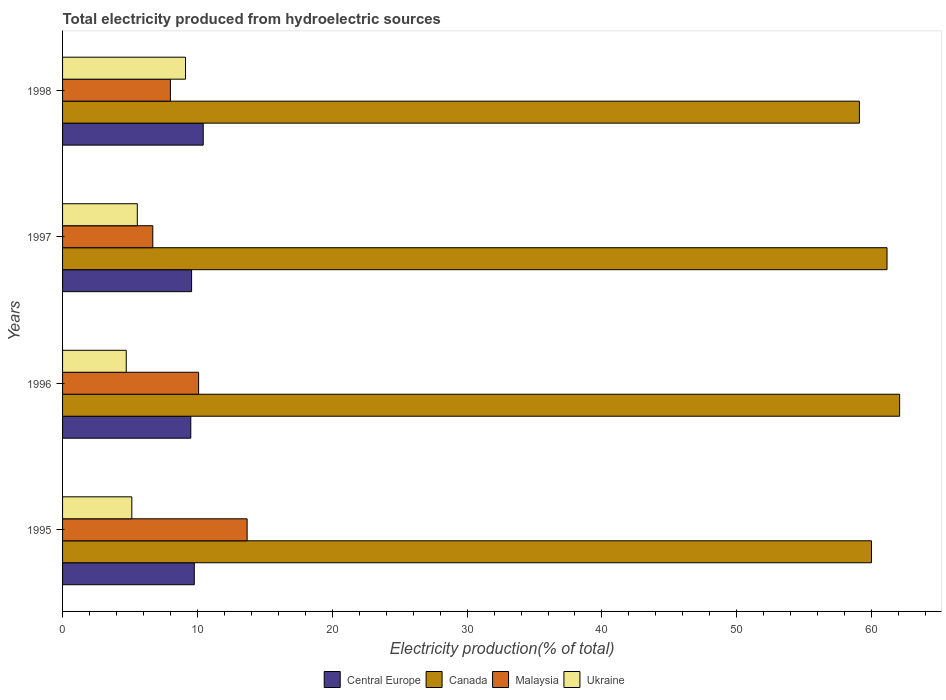How many different coloured bars are there?
Your response must be concise. 4. How many groups of bars are there?
Give a very brief answer. 4. Are the number of bars per tick equal to the number of legend labels?
Your answer should be very brief. Yes. How many bars are there on the 4th tick from the top?
Keep it short and to the point. 4. What is the total electricity produced in Ukraine in 1997?
Your answer should be very brief. 5.54. Across all years, what is the maximum total electricity produced in Ukraine?
Provide a short and direct response. 9.12. Across all years, what is the minimum total electricity produced in Malaysia?
Offer a terse response. 6.69. In which year was the total electricity produced in Central Europe minimum?
Ensure brevity in your answer.  1996. What is the total total electricity produced in Malaysia in the graph?
Your answer should be very brief. 38.46. What is the difference between the total electricity produced in Ukraine in 1995 and that in 1996?
Offer a terse response. 0.41. What is the difference between the total electricity produced in Ukraine in 1997 and the total electricity produced in Malaysia in 1995?
Offer a terse response. -8.14. What is the average total electricity produced in Central Europe per year?
Provide a succinct answer. 9.82. In the year 1996, what is the difference between the total electricity produced in Ukraine and total electricity produced in Malaysia?
Ensure brevity in your answer.  -5.37. What is the ratio of the total electricity produced in Central Europe in 1997 to that in 1998?
Offer a very short reply. 0.92. What is the difference between the highest and the second highest total electricity produced in Ukraine?
Provide a short and direct response. 3.57. What is the difference between the highest and the lowest total electricity produced in Canada?
Keep it short and to the point. 2.98. Is the sum of the total electricity produced in Canada in 1995 and 1997 greater than the maximum total electricity produced in Central Europe across all years?
Give a very brief answer. Yes. What does the 4th bar from the top in 1995 represents?
Make the answer very short. Central Europe. What does the 1st bar from the bottom in 1996 represents?
Provide a succinct answer. Central Europe. Is it the case that in every year, the sum of the total electricity produced in Central Europe and total electricity produced in Malaysia is greater than the total electricity produced in Canada?
Offer a terse response. No. How many bars are there?
Make the answer very short. 16. What is the difference between two consecutive major ticks on the X-axis?
Provide a short and direct response. 10. Does the graph contain any zero values?
Offer a very short reply. No. Does the graph contain grids?
Provide a short and direct response. No. How many legend labels are there?
Ensure brevity in your answer.  4. What is the title of the graph?
Offer a very short reply. Total electricity produced from hydroelectric sources. What is the Electricity production(% of total) in Central Europe in 1995?
Keep it short and to the point. 9.77. What is the Electricity production(% of total) of Canada in 1995?
Make the answer very short. 59.99. What is the Electricity production(% of total) of Malaysia in 1995?
Provide a succinct answer. 13.69. What is the Electricity production(% of total) in Ukraine in 1995?
Offer a terse response. 5.14. What is the Electricity production(% of total) in Central Europe in 1996?
Ensure brevity in your answer.  9.51. What is the Electricity production(% of total) in Canada in 1996?
Provide a short and direct response. 62.08. What is the Electricity production(% of total) in Malaysia in 1996?
Keep it short and to the point. 10.09. What is the Electricity production(% of total) of Ukraine in 1996?
Provide a succinct answer. 4.72. What is the Electricity production(% of total) in Central Europe in 1997?
Give a very brief answer. 9.57. What is the Electricity production(% of total) of Canada in 1997?
Your response must be concise. 61.14. What is the Electricity production(% of total) in Malaysia in 1997?
Provide a short and direct response. 6.69. What is the Electricity production(% of total) in Ukraine in 1997?
Offer a very short reply. 5.54. What is the Electricity production(% of total) of Central Europe in 1998?
Give a very brief answer. 10.43. What is the Electricity production(% of total) in Canada in 1998?
Ensure brevity in your answer.  59.09. What is the Electricity production(% of total) of Malaysia in 1998?
Give a very brief answer. 8. What is the Electricity production(% of total) in Ukraine in 1998?
Offer a terse response. 9.12. Across all years, what is the maximum Electricity production(% of total) of Central Europe?
Your response must be concise. 10.43. Across all years, what is the maximum Electricity production(% of total) in Canada?
Keep it short and to the point. 62.08. Across all years, what is the maximum Electricity production(% of total) of Malaysia?
Give a very brief answer. 13.69. Across all years, what is the maximum Electricity production(% of total) in Ukraine?
Your response must be concise. 9.12. Across all years, what is the minimum Electricity production(% of total) of Central Europe?
Your answer should be very brief. 9.51. Across all years, what is the minimum Electricity production(% of total) in Canada?
Your answer should be very brief. 59.09. Across all years, what is the minimum Electricity production(% of total) of Malaysia?
Your answer should be very brief. 6.69. Across all years, what is the minimum Electricity production(% of total) in Ukraine?
Keep it short and to the point. 4.72. What is the total Electricity production(% of total) of Central Europe in the graph?
Provide a short and direct response. 39.28. What is the total Electricity production(% of total) in Canada in the graph?
Your answer should be very brief. 242.29. What is the total Electricity production(% of total) in Malaysia in the graph?
Your answer should be very brief. 38.46. What is the total Electricity production(% of total) of Ukraine in the graph?
Offer a terse response. 24.52. What is the difference between the Electricity production(% of total) of Central Europe in 1995 and that in 1996?
Give a very brief answer. 0.26. What is the difference between the Electricity production(% of total) of Canada in 1995 and that in 1996?
Your response must be concise. -2.09. What is the difference between the Electricity production(% of total) of Malaysia in 1995 and that in 1996?
Your answer should be compact. 3.6. What is the difference between the Electricity production(% of total) in Ukraine in 1995 and that in 1996?
Your response must be concise. 0.41. What is the difference between the Electricity production(% of total) in Central Europe in 1995 and that in 1997?
Provide a succinct answer. 0.2. What is the difference between the Electricity production(% of total) of Canada in 1995 and that in 1997?
Offer a terse response. -1.15. What is the difference between the Electricity production(% of total) in Malaysia in 1995 and that in 1997?
Ensure brevity in your answer.  7. What is the difference between the Electricity production(% of total) of Ukraine in 1995 and that in 1997?
Ensure brevity in your answer.  -0.41. What is the difference between the Electricity production(% of total) in Central Europe in 1995 and that in 1998?
Offer a very short reply. -0.66. What is the difference between the Electricity production(% of total) of Canada in 1995 and that in 1998?
Your answer should be very brief. 0.89. What is the difference between the Electricity production(% of total) of Malaysia in 1995 and that in 1998?
Your answer should be very brief. 5.69. What is the difference between the Electricity production(% of total) in Ukraine in 1995 and that in 1998?
Your answer should be very brief. -3.98. What is the difference between the Electricity production(% of total) in Central Europe in 1996 and that in 1997?
Provide a short and direct response. -0.06. What is the difference between the Electricity production(% of total) in Canada in 1996 and that in 1997?
Your answer should be very brief. 0.94. What is the difference between the Electricity production(% of total) of Malaysia in 1996 and that in 1997?
Offer a terse response. 3.4. What is the difference between the Electricity production(% of total) of Ukraine in 1996 and that in 1997?
Make the answer very short. -0.82. What is the difference between the Electricity production(% of total) in Central Europe in 1996 and that in 1998?
Give a very brief answer. -0.92. What is the difference between the Electricity production(% of total) of Canada in 1996 and that in 1998?
Ensure brevity in your answer.  2.98. What is the difference between the Electricity production(% of total) of Malaysia in 1996 and that in 1998?
Provide a succinct answer. 2.09. What is the difference between the Electricity production(% of total) in Ukraine in 1996 and that in 1998?
Give a very brief answer. -4.39. What is the difference between the Electricity production(% of total) in Central Europe in 1997 and that in 1998?
Keep it short and to the point. -0.86. What is the difference between the Electricity production(% of total) in Canada in 1997 and that in 1998?
Your response must be concise. 2.05. What is the difference between the Electricity production(% of total) in Malaysia in 1997 and that in 1998?
Offer a terse response. -1.31. What is the difference between the Electricity production(% of total) in Ukraine in 1997 and that in 1998?
Ensure brevity in your answer.  -3.57. What is the difference between the Electricity production(% of total) in Central Europe in 1995 and the Electricity production(% of total) in Canada in 1996?
Ensure brevity in your answer.  -52.31. What is the difference between the Electricity production(% of total) in Central Europe in 1995 and the Electricity production(% of total) in Malaysia in 1996?
Give a very brief answer. -0.32. What is the difference between the Electricity production(% of total) in Central Europe in 1995 and the Electricity production(% of total) in Ukraine in 1996?
Provide a succinct answer. 5.05. What is the difference between the Electricity production(% of total) of Canada in 1995 and the Electricity production(% of total) of Malaysia in 1996?
Give a very brief answer. 49.9. What is the difference between the Electricity production(% of total) of Canada in 1995 and the Electricity production(% of total) of Ukraine in 1996?
Provide a short and direct response. 55.26. What is the difference between the Electricity production(% of total) of Malaysia in 1995 and the Electricity production(% of total) of Ukraine in 1996?
Offer a terse response. 8.96. What is the difference between the Electricity production(% of total) in Central Europe in 1995 and the Electricity production(% of total) in Canada in 1997?
Ensure brevity in your answer.  -51.37. What is the difference between the Electricity production(% of total) of Central Europe in 1995 and the Electricity production(% of total) of Malaysia in 1997?
Provide a succinct answer. 3.08. What is the difference between the Electricity production(% of total) in Central Europe in 1995 and the Electricity production(% of total) in Ukraine in 1997?
Your answer should be very brief. 4.23. What is the difference between the Electricity production(% of total) in Canada in 1995 and the Electricity production(% of total) in Malaysia in 1997?
Ensure brevity in your answer.  53.29. What is the difference between the Electricity production(% of total) in Canada in 1995 and the Electricity production(% of total) in Ukraine in 1997?
Provide a short and direct response. 54.44. What is the difference between the Electricity production(% of total) of Malaysia in 1995 and the Electricity production(% of total) of Ukraine in 1997?
Offer a very short reply. 8.14. What is the difference between the Electricity production(% of total) in Central Europe in 1995 and the Electricity production(% of total) in Canada in 1998?
Make the answer very short. -49.32. What is the difference between the Electricity production(% of total) of Central Europe in 1995 and the Electricity production(% of total) of Malaysia in 1998?
Your answer should be compact. 1.77. What is the difference between the Electricity production(% of total) in Central Europe in 1995 and the Electricity production(% of total) in Ukraine in 1998?
Provide a short and direct response. 0.65. What is the difference between the Electricity production(% of total) of Canada in 1995 and the Electricity production(% of total) of Malaysia in 1998?
Ensure brevity in your answer.  51.99. What is the difference between the Electricity production(% of total) of Canada in 1995 and the Electricity production(% of total) of Ukraine in 1998?
Keep it short and to the point. 50.87. What is the difference between the Electricity production(% of total) of Malaysia in 1995 and the Electricity production(% of total) of Ukraine in 1998?
Provide a succinct answer. 4.57. What is the difference between the Electricity production(% of total) in Central Europe in 1996 and the Electricity production(% of total) in Canada in 1997?
Provide a short and direct response. -51.63. What is the difference between the Electricity production(% of total) of Central Europe in 1996 and the Electricity production(% of total) of Malaysia in 1997?
Make the answer very short. 2.82. What is the difference between the Electricity production(% of total) in Central Europe in 1996 and the Electricity production(% of total) in Ukraine in 1997?
Your answer should be compact. 3.97. What is the difference between the Electricity production(% of total) in Canada in 1996 and the Electricity production(% of total) in Malaysia in 1997?
Keep it short and to the point. 55.38. What is the difference between the Electricity production(% of total) in Canada in 1996 and the Electricity production(% of total) in Ukraine in 1997?
Provide a short and direct response. 56.53. What is the difference between the Electricity production(% of total) of Malaysia in 1996 and the Electricity production(% of total) of Ukraine in 1997?
Your response must be concise. 4.55. What is the difference between the Electricity production(% of total) of Central Europe in 1996 and the Electricity production(% of total) of Canada in 1998?
Your answer should be very brief. -49.58. What is the difference between the Electricity production(% of total) of Central Europe in 1996 and the Electricity production(% of total) of Malaysia in 1998?
Your answer should be compact. 1.51. What is the difference between the Electricity production(% of total) of Central Europe in 1996 and the Electricity production(% of total) of Ukraine in 1998?
Provide a succinct answer. 0.39. What is the difference between the Electricity production(% of total) in Canada in 1996 and the Electricity production(% of total) in Malaysia in 1998?
Offer a terse response. 54.08. What is the difference between the Electricity production(% of total) in Canada in 1996 and the Electricity production(% of total) in Ukraine in 1998?
Make the answer very short. 52.96. What is the difference between the Electricity production(% of total) in Malaysia in 1996 and the Electricity production(% of total) in Ukraine in 1998?
Your answer should be compact. 0.97. What is the difference between the Electricity production(% of total) in Central Europe in 1997 and the Electricity production(% of total) in Canada in 1998?
Your answer should be very brief. -49.52. What is the difference between the Electricity production(% of total) of Central Europe in 1997 and the Electricity production(% of total) of Malaysia in 1998?
Offer a very short reply. 1.57. What is the difference between the Electricity production(% of total) in Central Europe in 1997 and the Electricity production(% of total) in Ukraine in 1998?
Provide a succinct answer. 0.45. What is the difference between the Electricity production(% of total) of Canada in 1997 and the Electricity production(% of total) of Malaysia in 1998?
Keep it short and to the point. 53.14. What is the difference between the Electricity production(% of total) in Canada in 1997 and the Electricity production(% of total) in Ukraine in 1998?
Make the answer very short. 52.02. What is the difference between the Electricity production(% of total) in Malaysia in 1997 and the Electricity production(% of total) in Ukraine in 1998?
Offer a very short reply. -2.43. What is the average Electricity production(% of total) of Central Europe per year?
Ensure brevity in your answer.  9.82. What is the average Electricity production(% of total) in Canada per year?
Ensure brevity in your answer.  60.57. What is the average Electricity production(% of total) of Malaysia per year?
Offer a very short reply. 9.62. What is the average Electricity production(% of total) in Ukraine per year?
Make the answer very short. 6.13. In the year 1995, what is the difference between the Electricity production(% of total) of Central Europe and Electricity production(% of total) of Canada?
Give a very brief answer. -50.22. In the year 1995, what is the difference between the Electricity production(% of total) in Central Europe and Electricity production(% of total) in Malaysia?
Your answer should be compact. -3.92. In the year 1995, what is the difference between the Electricity production(% of total) in Central Europe and Electricity production(% of total) in Ukraine?
Offer a terse response. 4.63. In the year 1995, what is the difference between the Electricity production(% of total) in Canada and Electricity production(% of total) in Malaysia?
Your answer should be compact. 46.3. In the year 1995, what is the difference between the Electricity production(% of total) in Canada and Electricity production(% of total) in Ukraine?
Provide a short and direct response. 54.85. In the year 1995, what is the difference between the Electricity production(% of total) in Malaysia and Electricity production(% of total) in Ukraine?
Keep it short and to the point. 8.55. In the year 1996, what is the difference between the Electricity production(% of total) of Central Europe and Electricity production(% of total) of Canada?
Your answer should be very brief. -52.57. In the year 1996, what is the difference between the Electricity production(% of total) in Central Europe and Electricity production(% of total) in Malaysia?
Keep it short and to the point. -0.58. In the year 1996, what is the difference between the Electricity production(% of total) in Central Europe and Electricity production(% of total) in Ukraine?
Ensure brevity in your answer.  4.79. In the year 1996, what is the difference between the Electricity production(% of total) of Canada and Electricity production(% of total) of Malaysia?
Ensure brevity in your answer.  51.99. In the year 1996, what is the difference between the Electricity production(% of total) in Canada and Electricity production(% of total) in Ukraine?
Ensure brevity in your answer.  57.35. In the year 1996, what is the difference between the Electricity production(% of total) in Malaysia and Electricity production(% of total) in Ukraine?
Your response must be concise. 5.37. In the year 1997, what is the difference between the Electricity production(% of total) in Central Europe and Electricity production(% of total) in Canada?
Your answer should be compact. -51.57. In the year 1997, what is the difference between the Electricity production(% of total) in Central Europe and Electricity production(% of total) in Malaysia?
Keep it short and to the point. 2.88. In the year 1997, what is the difference between the Electricity production(% of total) in Central Europe and Electricity production(% of total) in Ukraine?
Give a very brief answer. 4.03. In the year 1997, what is the difference between the Electricity production(% of total) of Canada and Electricity production(% of total) of Malaysia?
Keep it short and to the point. 54.45. In the year 1997, what is the difference between the Electricity production(% of total) in Canada and Electricity production(% of total) in Ukraine?
Give a very brief answer. 55.6. In the year 1997, what is the difference between the Electricity production(% of total) in Malaysia and Electricity production(% of total) in Ukraine?
Your answer should be very brief. 1.15. In the year 1998, what is the difference between the Electricity production(% of total) in Central Europe and Electricity production(% of total) in Canada?
Offer a terse response. -48.66. In the year 1998, what is the difference between the Electricity production(% of total) in Central Europe and Electricity production(% of total) in Malaysia?
Make the answer very short. 2.43. In the year 1998, what is the difference between the Electricity production(% of total) in Central Europe and Electricity production(% of total) in Ukraine?
Offer a terse response. 1.31. In the year 1998, what is the difference between the Electricity production(% of total) of Canada and Electricity production(% of total) of Malaysia?
Offer a very short reply. 51.1. In the year 1998, what is the difference between the Electricity production(% of total) of Canada and Electricity production(% of total) of Ukraine?
Give a very brief answer. 49.98. In the year 1998, what is the difference between the Electricity production(% of total) of Malaysia and Electricity production(% of total) of Ukraine?
Offer a very short reply. -1.12. What is the ratio of the Electricity production(% of total) in Central Europe in 1995 to that in 1996?
Offer a very short reply. 1.03. What is the ratio of the Electricity production(% of total) of Canada in 1995 to that in 1996?
Ensure brevity in your answer.  0.97. What is the ratio of the Electricity production(% of total) of Malaysia in 1995 to that in 1996?
Keep it short and to the point. 1.36. What is the ratio of the Electricity production(% of total) of Ukraine in 1995 to that in 1996?
Keep it short and to the point. 1.09. What is the ratio of the Electricity production(% of total) in Canada in 1995 to that in 1997?
Keep it short and to the point. 0.98. What is the ratio of the Electricity production(% of total) of Malaysia in 1995 to that in 1997?
Provide a succinct answer. 2.05. What is the ratio of the Electricity production(% of total) of Ukraine in 1995 to that in 1997?
Your answer should be very brief. 0.93. What is the ratio of the Electricity production(% of total) of Central Europe in 1995 to that in 1998?
Provide a short and direct response. 0.94. What is the ratio of the Electricity production(% of total) in Canada in 1995 to that in 1998?
Make the answer very short. 1.02. What is the ratio of the Electricity production(% of total) in Malaysia in 1995 to that in 1998?
Keep it short and to the point. 1.71. What is the ratio of the Electricity production(% of total) of Ukraine in 1995 to that in 1998?
Keep it short and to the point. 0.56. What is the ratio of the Electricity production(% of total) in Central Europe in 1996 to that in 1997?
Keep it short and to the point. 0.99. What is the ratio of the Electricity production(% of total) of Canada in 1996 to that in 1997?
Ensure brevity in your answer.  1.02. What is the ratio of the Electricity production(% of total) in Malaysia in 1996 to that in 1997?
Provide a succinct answer. 1.51. What is the ratio of the Electricity production(% of total) of Ukraine in 1996 to that in 1997?
Give a very brief answer. 0.85. What is the ratio of the Electricity production(% of total) in Central Europe in 1996 to that in 1998?
Your answer should be very brief. 0.91. What is the ratio of the Electricity production(% of total) in Canada in 1996 to that in 1998?
Make the answer very short. 1.05. What is the ratio of the Electricity production(% of total) in Malaysia in 1996 to that in 1998?
Your answer should be very brief. 1.26. What is the ratio of the Electricity production(% of total) of Ukraine in 1996 to that in 1998?
Your response must be concise. 0.52. What is the ratio of the Electricity production(% of total) of Central Europe in 1997 to that in 1998?
Provide a succinct answer. 0.92. What is the ratio of the Electricity production(% of total) of Canada in 1997 to that in 1998?
Make the answer very short. 1.03. What is the ratio of the Electricity production(% of total) in Malaysia in 1997 to that in 1998?
Keep it short and to the point. 0.84. What is the ratio of the Electricity production(% of total) of Ukraine in 1997 to that in 1998?
Your response must be concise. 0.61. What is the difference between the highest and the second highest Electricity production(% of total) in Central Europe?
Offer a terse response. 0.66. What is the difference between the highest and the second highest Electricity production(% of total) of Canada?
Provide a succinct answer. 0.94. What is the difference between the highest and the second highest Electricity production(% of total) of Malaysia?
Provide a succinct answer. 3.6. What is the difference between the highest and the second highest Electricity production(% of total) in Ukraine?
Provide a succinct answer. 3.57. What is the difference between the highest and the lowest Electricity production(% of total) of Central Europe?
Offer a very short reply. 0.92. What is the difference between the highest and the lowest Electricity production(% of total) in Canada?
Your answer should be very brief. 2.98. What is the difference between the highest and the lowest Electricity production(% of total) of Malaysia?
Your response must be concise. 7. What is the difference between the highest and the lowest Electricity production(% of total) in Ukraine?
Your answer should be very brief. 4.39. 